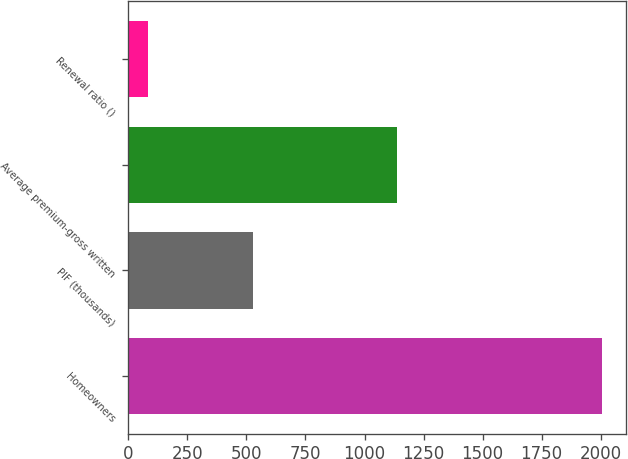Convert chart to OTSL. <chart><loc_0><loc_0><loc_500><loc_500><bar_chart><fcel>Homeowners<fcel>PIF (thousands)<fcel>Average premium-gross written<fcel>Renewal ratio ()<nl><fcel>2006<fcel>527<fcel>1136<fcel>84<nl></chart> 